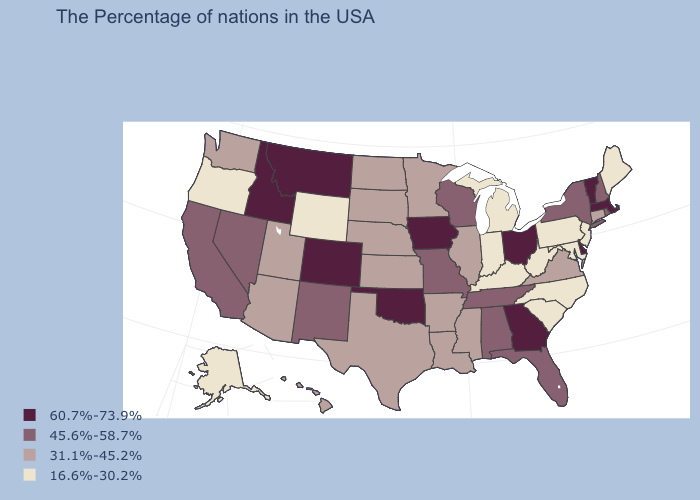Name the states that have a value in the range 60.7%-73.9%?
Concise answer only. Massachusetts, Vermont, Delaware, Ohio, Georgia, Iowa, Oklahoma, Colorado, Montana, Idaho. Which states have the lowest value in the USA?
Be succinct. Maine, New Jersey, Maryland, Pennsylvania, North Carolina, South Carolina, West Virginia, Michigan, Kentucky, Indiana, Wyoming, Oregon, Alaska. Which states have the lowest value in the USA?
Keep it brief. Maine, New Jersey, Maryland, Pennsylvania, North Carolina, South Carolina, West Virginia, Michigan, Kentucky, Indiana, Wyoming, Oregon, Alaska. What is the highest value in the USA?
Be succinct. 60.7%-73.9%. Which states have the lowest value in the USA?
Be succinct. Maine, New Jersey, Maryland, Pennsylvania, North Carolina, South Carolina, West Virginia, Michigan, Kentucky, Indiana, Wyoming, Oregon, Alaska. What is the value of Maryland?
Short answer required. 16.6%-30.2%. What is the highest value in states that border Massachusetts?
Answer briefly. 60.7%-73.9%. What is the value of Kansas?
Short answer required. 31.1%-45.2%. Name the states that have a value in the range 45.6%-58.7%?
Write a very short answer. Rhode Island, New Hampshire, New York, Florida, Alabama, Tennessee, Wisconsin, Missouri, New Mexico, Nevada, California. Does the map have missing data?
Be succinct. No. Does the first symbol in the legend represent the smallest category?
Give a very brief answer. No. Among the states that border Rhode Island , does Connecticut have the lowest value?
Keep it brief. Yes. What is the value of Kansas?
Write a very short answer. 31.1%-45.2%. What is the highest value in the West ?
Give a very brief answer. 60.7%-73.9%. What is the value of Delaware?
Give a very brief answer. 60.7%-73.9%. 